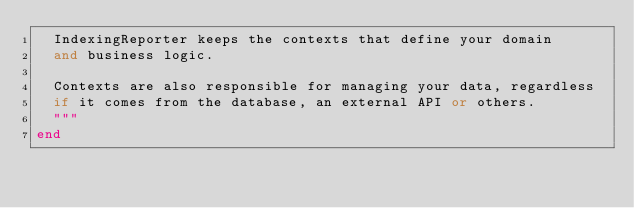Convert code to text. <code><loc_0><loc_0><loc_500><loc_500><_Elixir_>  IndexingReporter keeps the contexts that define your domain
  and business logic.

  Contexts are also responsible for managing your data, regardless
  if it comes from the database, an external API or others.
  """
end
</code> 